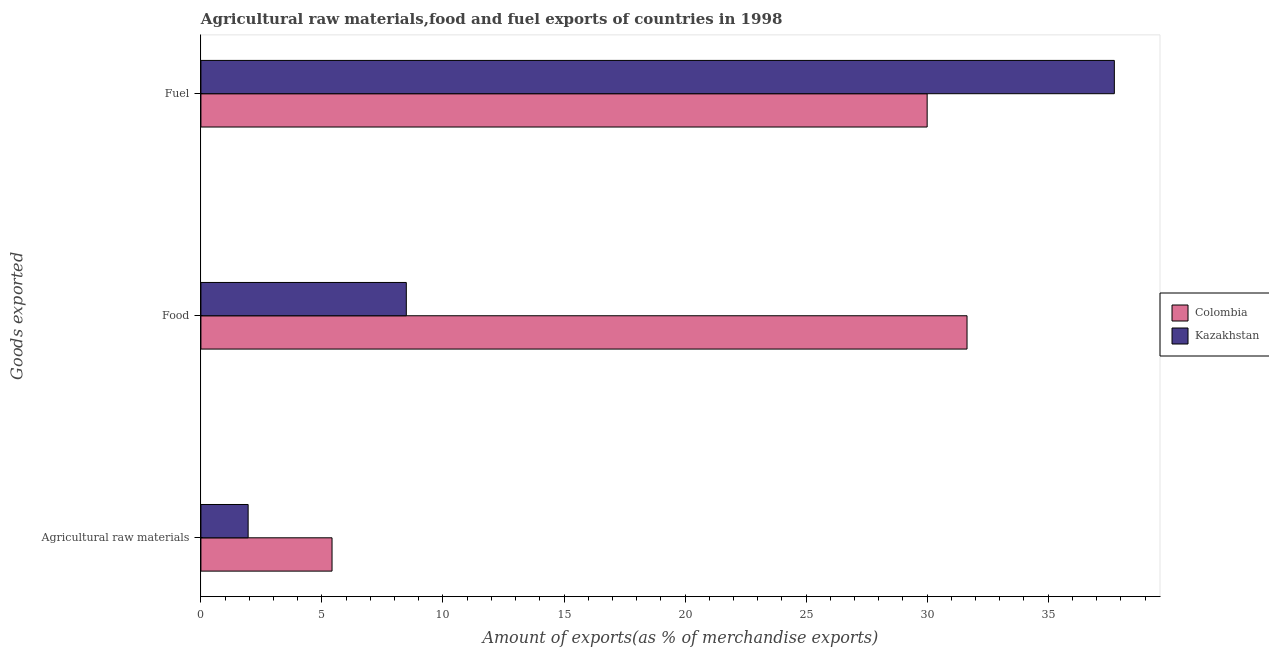Are the number of bars per tick equal to the number of legend labels?
Give a very brief answer. Yes. Are the number of bars on each tick of the Y-axis equal?
Ensure brevity in your answer.  Yes. How many bars are there on the 3rd tick from the bottom?
Keep it short and to the point. 2. What is the label of the 3rd group of bars from the top?
Your answer should be compact. Agricultural raw materials. What is the percentage of food exports in Kazakhstan?
Provide a short and direct response. 8.48. Across all countries, what is the maximum percentage of raw materials exports?
Give a very brief answer. 5.42. Across all countries, what is the minimum percentage of food exports?
Provide a succinct answer. 8.48. In which country was the percentage of food exports maximum?
Offer a very short reply. Colombia. In which country was the percentage of food exports minimum?
Your answer should be very brief. Kazakhstan. What is the total percentage of fuel exports in the graph?
Ensure brevity in your answer.  67.73. What is the difference between the percentage of raw materials exports in Kazakhstan and that in Colombia?
Give a very brief answer. -3.47. What is the difference between the percentage of fuel exports in Colombia and the percentage of raw materials exports in Kazakhstan?
Your response must be concise. 28.05. What is the average percentage of fuel exports per country?
Your response must be concise. 33.87. What is the difference between the percentage of food exports and percentage of fuel exports in Kazakhstan?
Offer a terse response. -29.25. In how many countries, is the percentage of fuel exports greater than 12 %?
Ensure brevity in your answer.  2. What is the ratio of the percentage of food exports in Kazakhstan to that in Colombia?
Provide a succinct answer. 0.27. Is the percentage of raw materials exports in Kazakhstan less than that in Colombia?
Offer a terse response. Yes. Is the difference between the percentage of raw materials exports in Colombia and Kazakhstan greater than the difference between the percentage of fuel exports in Colombia and Kazakhstan?
Offer a very short reply. Yes. What is the difference between the highest and the second highest percentage of fuel exports?
Your response must be concise. 7.73. What is the difference between the highest and the lowest percentage of fuel exports?
Keep it short and to the point. 7.73. In how many countries, is the percentage of fuel exports greater than the average percentage of fuel exports taken over all countries?
Your response must be concise. 1. Is the sum of the percentage of raw materials exports in Kazakhstan and Colombia greater than the maximum percentage of fuel exports across all countries?
Offer a very short reply. No. What does the 2nd bar from the bottom in Fuel represents?
Keep it short and to the point. Kazakhstan. How many bars are there?
Your response must be concise. 6. Does the graph contain any zero values?
Offer a very short reply. No. How many legend labels are there?
Offer a terse response. 2. How are the legend labels stacked?
Give a very brief answer. Vertical. What is the title of the graph?
Provide a short and direct response. Agricultural raw materials,food and fuel exports of countries in 1998. What is the label or title of the X-axis?
Offer a very short reply. Amount of exports(as % of merchandise exports). What is the label or title of the Y-axis?
Provide a succinct answer. Goods exported. What is the Amount of exports(as % of merchandise exports) of Colombia in Agricultural raw materials?
Give a very brief answer. 5.42. What is the Amount of exports(as % of merchandise exports) of Kazakhstan in Agricultural raw materials?
Keep it short and to the point. 1.95. What is the Amount of exports(as % of merchandise exports) of Colombia in Food?
Give a very brief answer. 31.65. What is the Amount of exports(as % of merchandise exports) of Kazakhstan in Food?
Your response must be concise. 8.48. What is the Amount of exports(as % of merchandise exports) in Colombia in Fuel?
Offer a very short reply. 30. What is the Amount of exports(as % of merchandise exports) in Kazakhstan in Fuel?
Your answer should be very brief. 37.73. Across all Goods exported, what is the maximum Amount of exports(as % of merchandise exports) of Colombia?
Your answer should be compact. 31.65. Across all Goods exported, what is the maximum Amount of exports(as % of merchandise exports) in Kazakhstan?
Provide a short and direct response. 37.73. Across all Goods exported, what is the minimum Amount of exports(as % of merchandise exports) in Colombia?
Your response must be concise. 5.42. Across all Goods exported, what is the minimum Amount of exports(as % of merchandise exports) of Kazakhstan?
Provide a short and direct response. 1.95. What is the total Amount of exports(as % of merchandise exports) of Colombia in the graph?
Make the answer very short. 67.07. What is the total Amount of exports(as % of merchandise exports) of Kazakhstan in the graph?
Your response must be concise. 48.17. What is the difference between the Amount of exports(as % of merchandise exports) in Colombia in Agricultural raw materials and that in Food?
Provide a succinct answer. -26.23. What is the difference between the Amount of exports(as % of merchandise exports) in Kazakhstan in Agricultural raw materials and that in Food?
Offer a very short reply. -6.53. What is the difference between the Amount of exports(as % of merchandise exports) of Colombia in Agricultural raw materials and that in Fuel?
Offer a very short reply. -24.58. What is the difference between the Amount of exports(as % of merchandise exports) of Kazakhstan in Agricultural raw materials and that in Fuel?
Make the answer very short. -35.78. What is the difference between the Amount of exports(as % of merchandise exports) in Colombia in Food and that in Fuel?
Your answer should be very brief. 1.65. What is the difference between the Amount of exports(as % of merchandise exports) of Kazakhstan in Food and that in Fuel?
Your answer should be very brief. -29.25. What is the difference between the Amount of exports(as % of merchandise exports) in Colombia in Agricultural raw materials and the Amount of exports(as % of merchandise exports) in Kazakhstan in Food?
Your answer should be compact. -3.07. What is the difference between the Amount of exports(as % of merchandise exports) in Colombia in Agricultural raw materials and the Amount of exports(as % of merchandise exports) in Kazakhstan in Fuel?
Offer a very short reply. -32.32. What is the difference between the Amount of exports(as % of merchandise exports) in Colombia in Food and the Amount of exports(as % of merchandise exports) in Kazakhstan in Fuel?
Ensure brevity in your answer.  -6.09. What is the average Amount of exports(as % of merchandise exports) of Colombia per Goods exported?
Provide a short and direct response. 22.36. What is the average Amount of exports(as % of merchandise exports) in Kazakhstan per Goods exported?
Ensure brevity in your answer.  16.06. What is the difference between the Amount of exports(as % of merchandise exports) in Colombia and Amount of exports(as % of merchandise exports) in Kazakhstan in Agricultural raw materials?
Provide a succinct answer. 3.47. What is the difference between the Amount of exports(as % of merchandise exports) of Colombia and Amount of exports(as % of merchandise exports) of Kazakhstan in Food?
Offer a terse response. 23.16. What is the difference between the Amount of exports(as % of merchandise exports) in Colombia and Amount of exports(as % of merchandise exports) in Kazakhstan in Fuel?
Ensure brevity in your answer.  -7.73. What is the ratio of the Amount of exports(as % of merchandise exports) of Colombia in Agricultural raw materials to that in Food?
Provide a short and direct response. 0.17. What is the ratio of the Amount of exports(as % of merchandise exports) in Kazakhstan in Agricultural raw materials to that in Food?
Offer a terse response. 0.23. What is the ratio of the Amount of exports(as % of merchandise exports) in Colombia in Agricultural raw materials to that in Fuel?
Offer a terse response. 0.18. What is the ratio of the Amount of exports(as % of merchandise exports) of Kazakhstan in Agricultural raw materials to that in Fuel?
Offer a very short reply. 0.05. What is the ratio of the Amount of exports(as % of merchandise exports) of Colombia in Food to that in Fuel?
Ensure brevity in your answer.  1.05. What is the ratio of the Amount of exports(as % of merchandise exports) in Kazakhstan in Food to that in Fuel?
Your answer should be very brief. 0.22. What is the difference between the highest and the second highest Amount of exports(as % of merchandise exports) in Colombia?
Provide a short and direct response. 1.65. What is the difference between the highest and the second highest Amount of exports(as % of merchandise exports) of Kazakhstan?
Give a very brief answer. 29.25. What is the difference between the highest and the lowest Amount of exports(as % of merchandise exports) of Colombia?
Provide a succinct answer. 26.23. What is the difference between the highest and the lowest Amount of exports(as % of merchandise exports) in Kazakhstan?
Your answer should be compact. 35.78. 